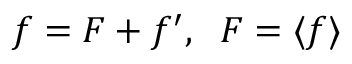<formula> <loc_0><loc_0><loc_500><loc_500>f = F + f ^ { \prime } , \, F = \langle { f } \rangle</formula> 